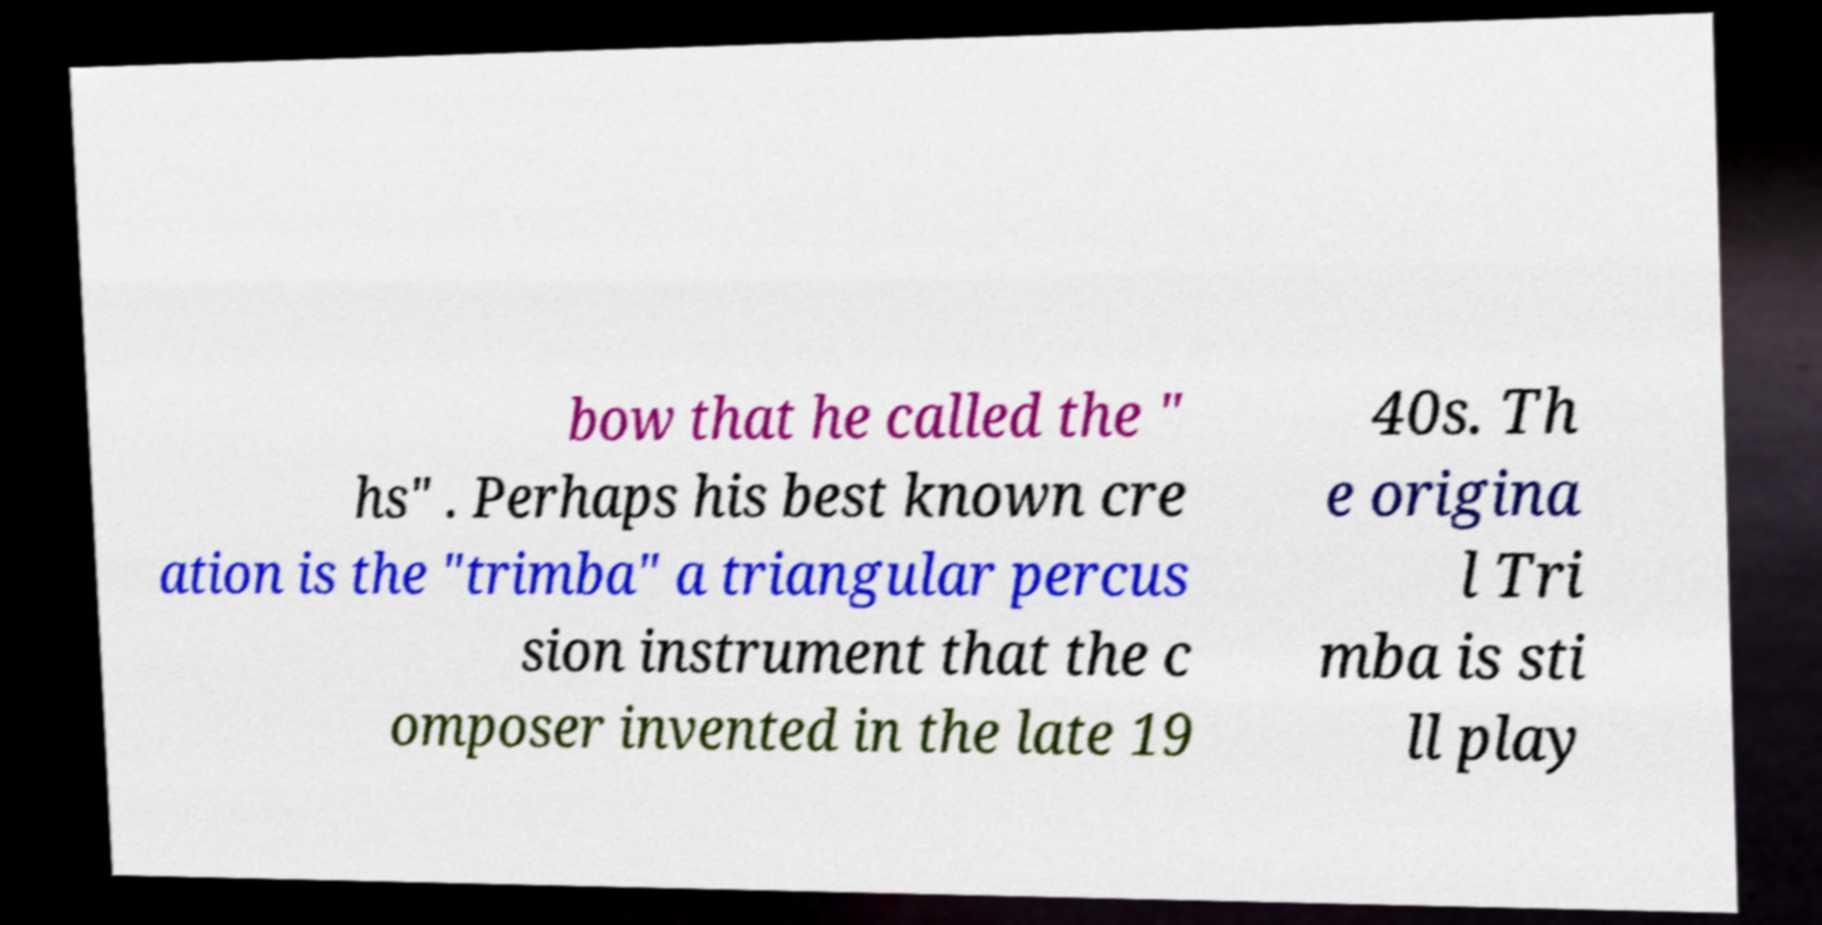I need the written content from this picture converted into text. Can you do that? bow that he called the " hs" . Perhaps his best known cre ation is the "trimba" a triangular percus sion instrument that the c omposer invented in the late 19 40s. Th e origina l Tri mba is sti ll play 